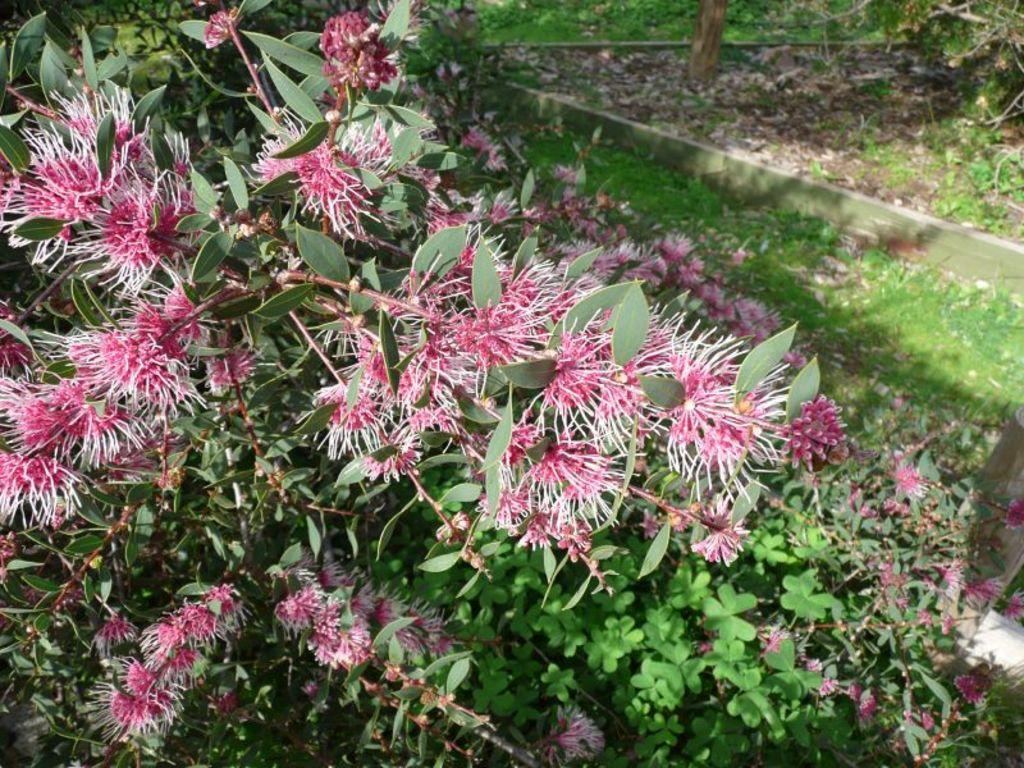Describe this image in one or two sentences. This picture might be taken outside of the city and it is sunny. In this image, we can see planets with some flowers. in the background, we can also see some trees, at the bottom there are some plants and grass. 